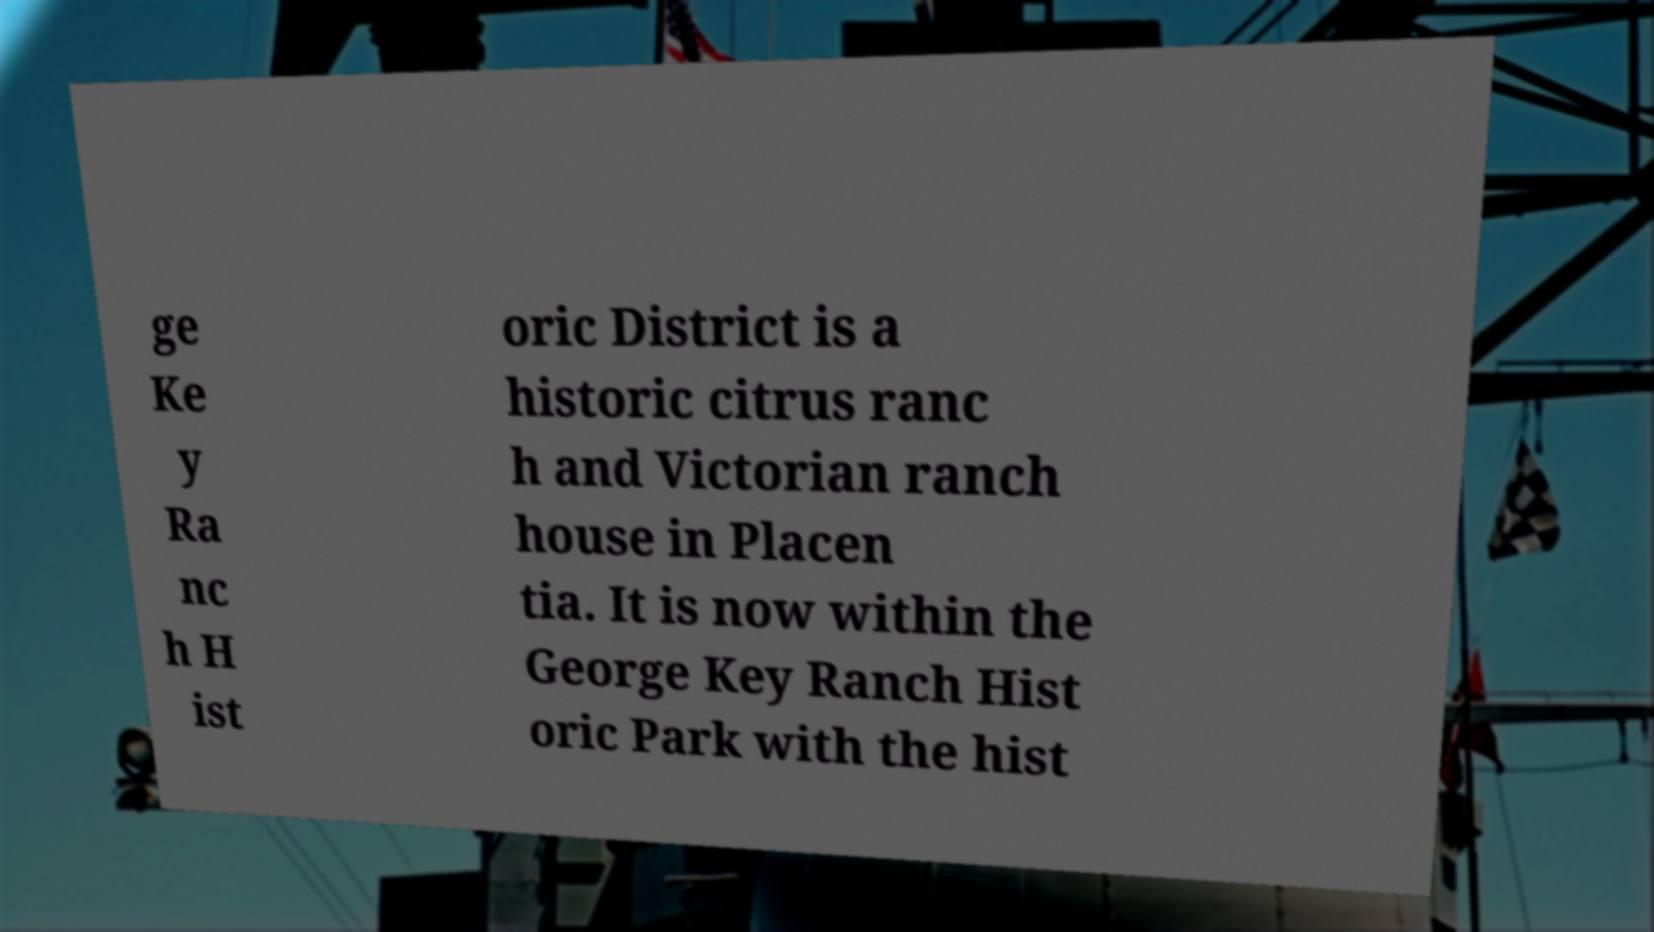Could you extract and type out the text from this image? ge Ke y Ra nc h H ist oric District is a historic citrus ranc h and Victorian ranch house in Placen tia. It is now within the George Key Ranch Hist oric Park with the hist 